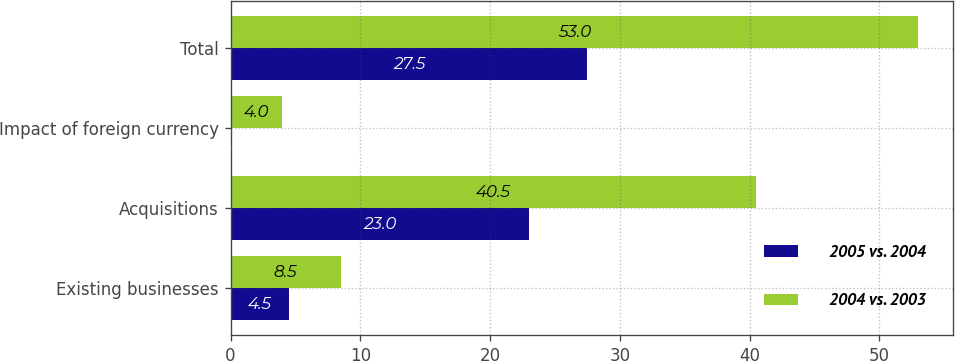<chart> <loc_0><loc_0><loc_500><loc_500><stacked_bar_chart><ecel><fcel>Existing businesses<fcel>Acquisitions<fcel>Impact of foreign currency<fcel>Total<nl><fcel>2005 vs. 2004<fcel>4.5<fcel>23<fcel>0<fcel>27.5<nl><fcel>2004 vs. 2003<fcel>8.5<fcel>40.5<fcel>4<fcel>53<nl></chart> 